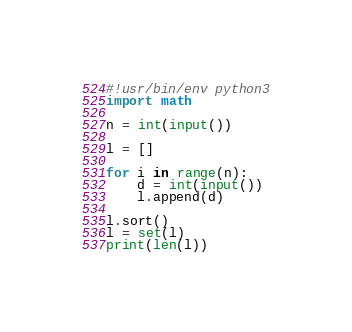<code> <loc_0><loc_0><loc_500><loc_500><_Python_>#!usr/bin/env python3
import math

n = int(input())

l = []

for i in range(n):
    d = int(input())
    l.append(d)

l.sort()
l = set(l)
print(len(l))</code> 